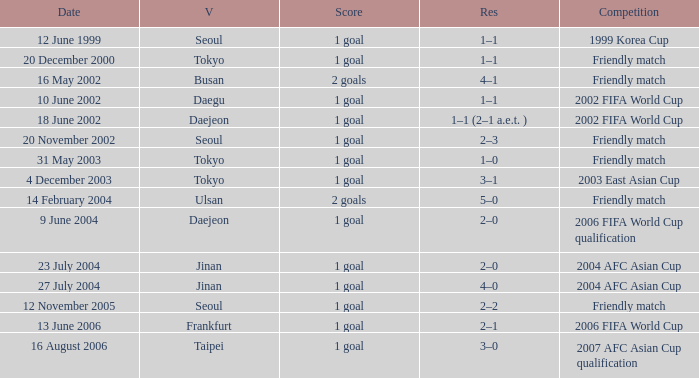What was the score of the game played on 16 August 2006? 1 goal. 